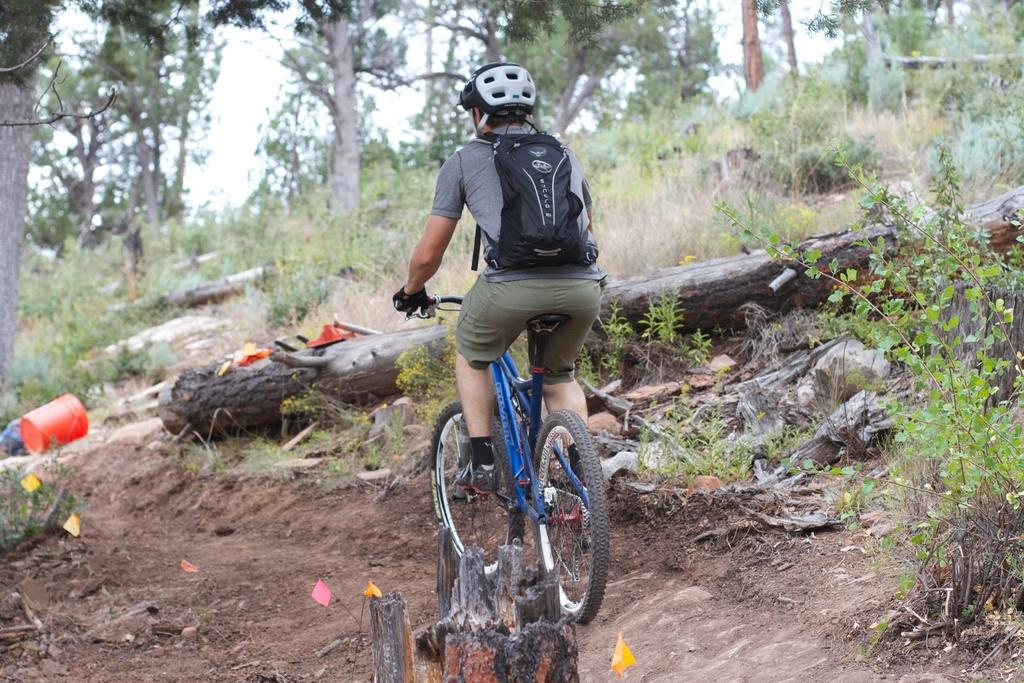What is the person in the image doing? There is a person riding a bicycle in the image. What type of vegetation can be seen in the image? There are plants, grass, and trees in the image. What is visible in the background of the image? The sky is visible in the background of the image. What type of apparatus is being used by the geese in the image? There are no geese present in the image, and therefore no apparatus can be associated with them. 